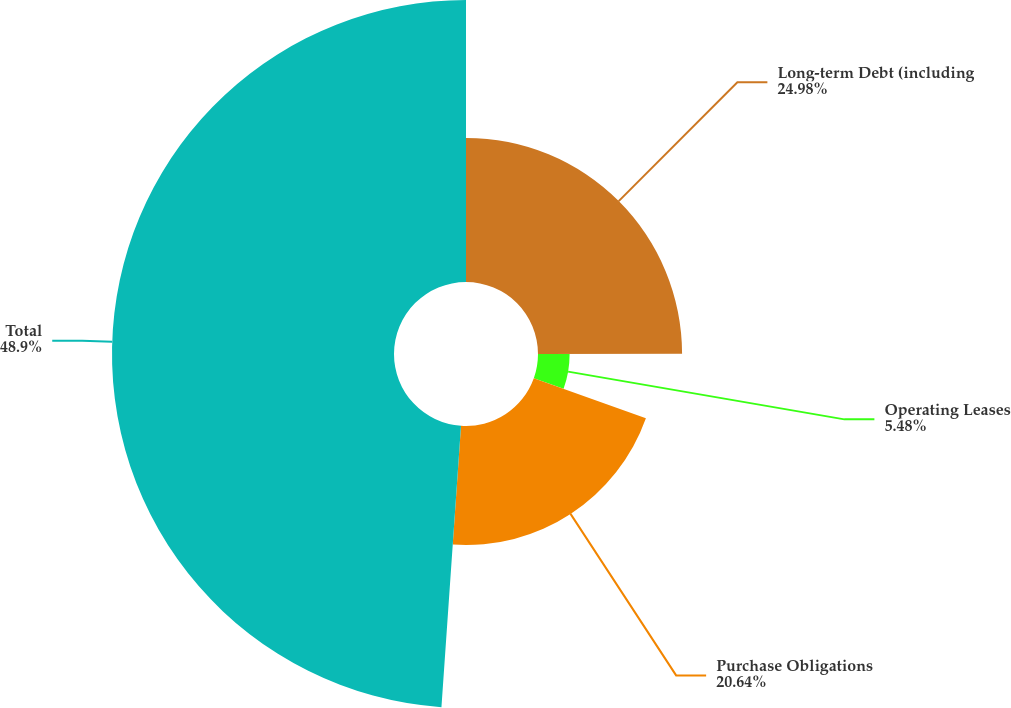Convert chart. <chart><loc_0><loc_0><loc_500><loc_500><pie_chart><fcel>Long-term Debt (including<fcel>Operating Leases<fcel>Purchase Obligations<fcel>Total<nl><fcel>24.98%<fcel>5.48%<fcel>20.64%<fcel>48.89%<nl></chart> 